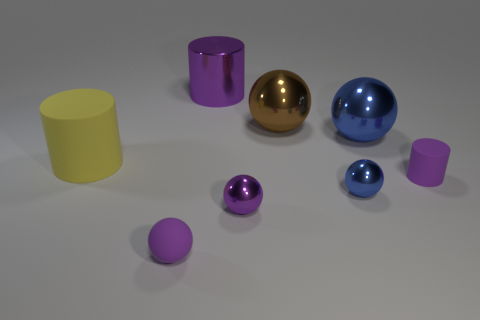There is a large metallic object that is right of the tiny metal thing behind the small purple metallic thing; what color is it? blue 